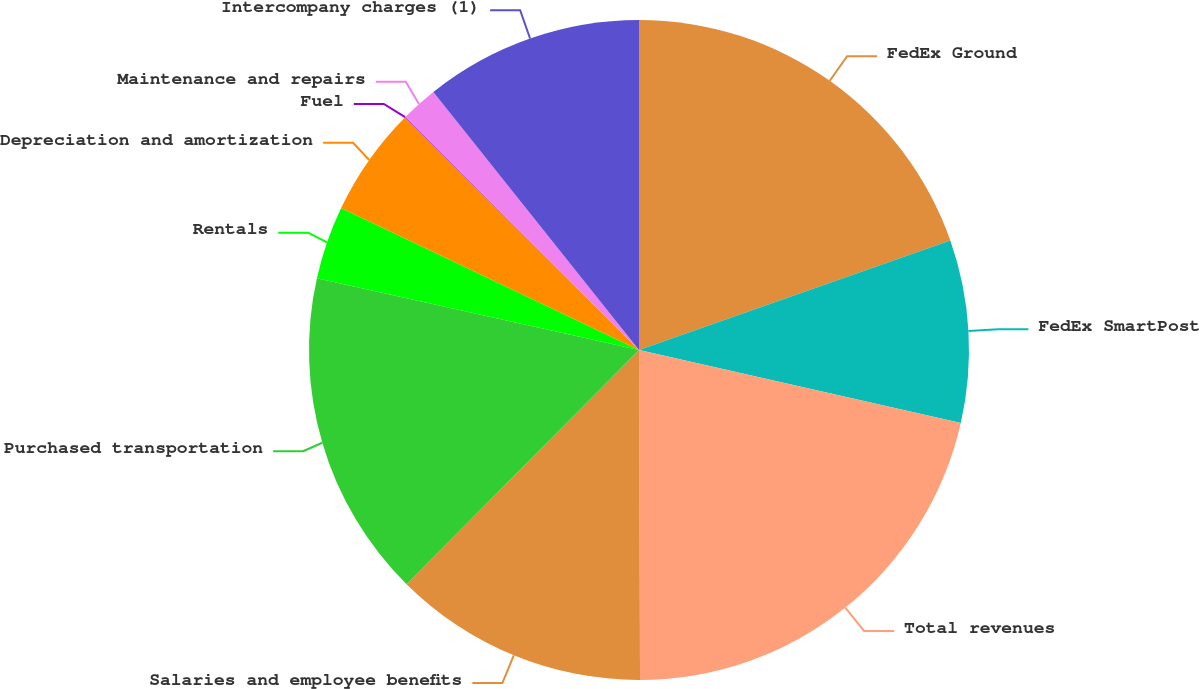<chart> <loc_0><loc_0><loc_500><loc_500><pie_chart><fcel>FedEx Ground<fcel>FedEx SmartPost<fcel>Total revenues<fcel>Salaries and employee benefits<fcel>Purchased transportation<fcel>Rentals<fcel>Depreciation and amortization<fcel>Fuel<fcel>Maintenance and repairs<fcel>Intercompany charges (1)<nl><fcel>19.62%<fcel>8.93%<fcel>21.4%<fcel>12.49%<fcel>16.05%<fcel>3.59%<fcel>5.37%<fcel>0.03%<fcel>1.81%<fcel>10.71%<nl></chart> 